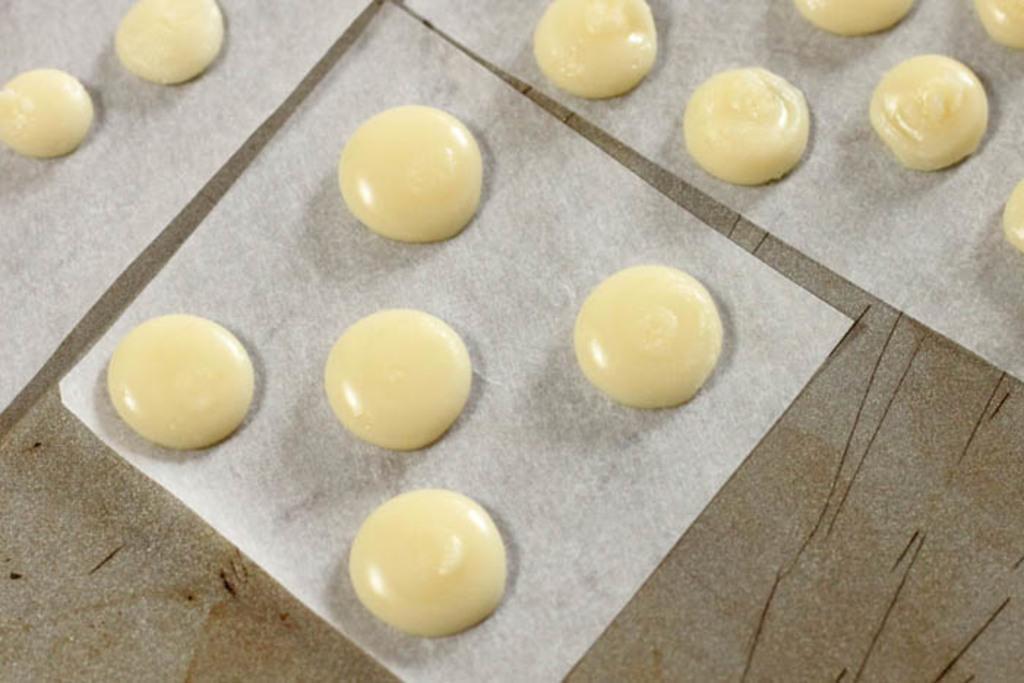Please provide a concise description of this image. In this image, we can see some food items on white colored objects is placed on the surface. 